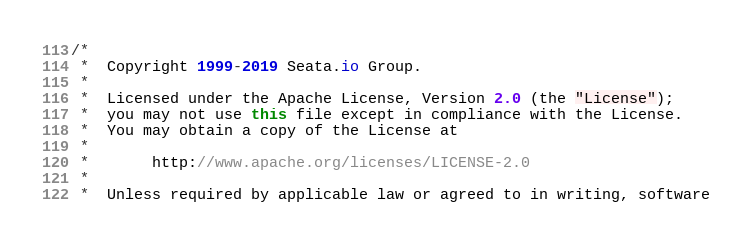Convert code to text. <code><loc_0><loc_0><loc_500><loc_500><_Java_>/*
 *  Copyright 1999-2019 Seata.io Group.
 *
 *  Licensed under the Apache License, Version 2.0 (the "License");
 *  you may not use this file except in compliance with the License.
 *  You may obtain a copy of the License at
 *
 *       http://www.apache.org/licenses/LICENSE-2.0
 *
 *  Unless required by applicable law or agreed to in writing, software</code> 